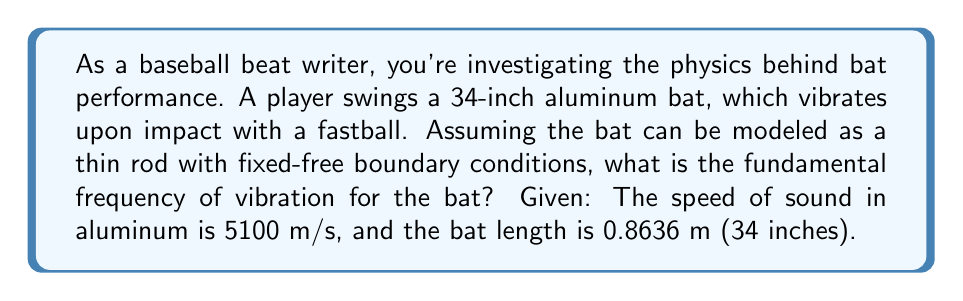What is the answer to this math problem? To solve this problem, we'll use the wave equation for transverse vibrations of a thin rod with fixed-free boundary conditions. The steps are as follows:

1) For a thin rod with fixed-free boundary conditions, the frequency equation is:

   $$\cos(kL) \cosh(kL) = -1$$

   where $k$ is the wavenumber and $L$ is the length of the rod.

2) The fundamental mode corresponds to the smallest non-zero solution of this equation. This occurs when:

   $$kL \approx 1.875$$

3) The relationship between frequency $f$, wavenumber $k$, and wave speed $c$ is:

   $$f = \frac{c k}{2\pi}$$

4) For a thin rod, the wave speed $c$ is equal to the speed of sound in the material. Here, $c = 5100$ m/s for aluminum.

5) Substituting the values:

   $$f = \frac{5100 \cdot 1.875}{2\pi \cdot 0.8636} \approx 176.8 \text{ Hz}$$

6) Rounding to the nearest whole number:

   $$f \approx 177 \text{ Hz}$$

This frequency represents the fundamental mode of vibration for the bat upon impact.
Answer: 177 Hz 